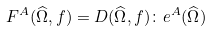<formula> <loc_0><loc_0><loc_500><loc_500>F ^ { A } ( \widehat { \Omega } , f ) = { D } ( \widehat { \Omega } , f ) \colon { e } ^ { A } ( \widehat { \Omega } ) \,</formula> 